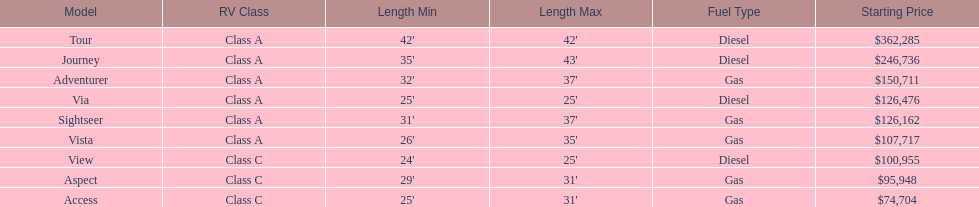How many models are available in lengths longer than 30 feet? 7. 